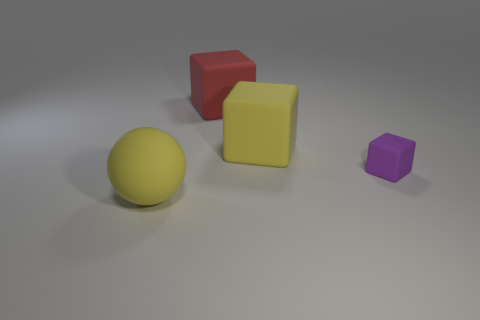What color is the small object that is the same material as the large yellow ball?
Offer a terse response. Purple. Does the big matte block that is in front of the big red matte thing have the same color as the large thing that is in front of the purple thing?
Provide a short and direct response. Yes. How many cubes are matte objects or big red objects?
Your answer should be compact. 3. Are there the same number of yellow matte cubes that are in front of the purple object and large yellow matte balls?
Your answer should be very brief. No. What material is the large yellow object that is behind the big yellow matte object that is in front of the block in front of the large yellow cube made of?
Keep it short and to the point. Rubber. What material is the large block that is the same color as the large matte ball?
Your answer should be very brief. Rubber. How many things are things that are in front of the large yellow block or red things?
Your answer should be compact. 3. What number of things are either large matte spheres or big yellow matte things that are in front of the small purple matte object?
Provide a short and direct response. 1. How many purple cubes are to the left of the purple matte block in front of the yellow object to the right of the yellow ball?
Provide a short and direct response. 0. What material is the yellow object that is the same size as the ball?
Ensure brevity in your answer.  Rubber. 